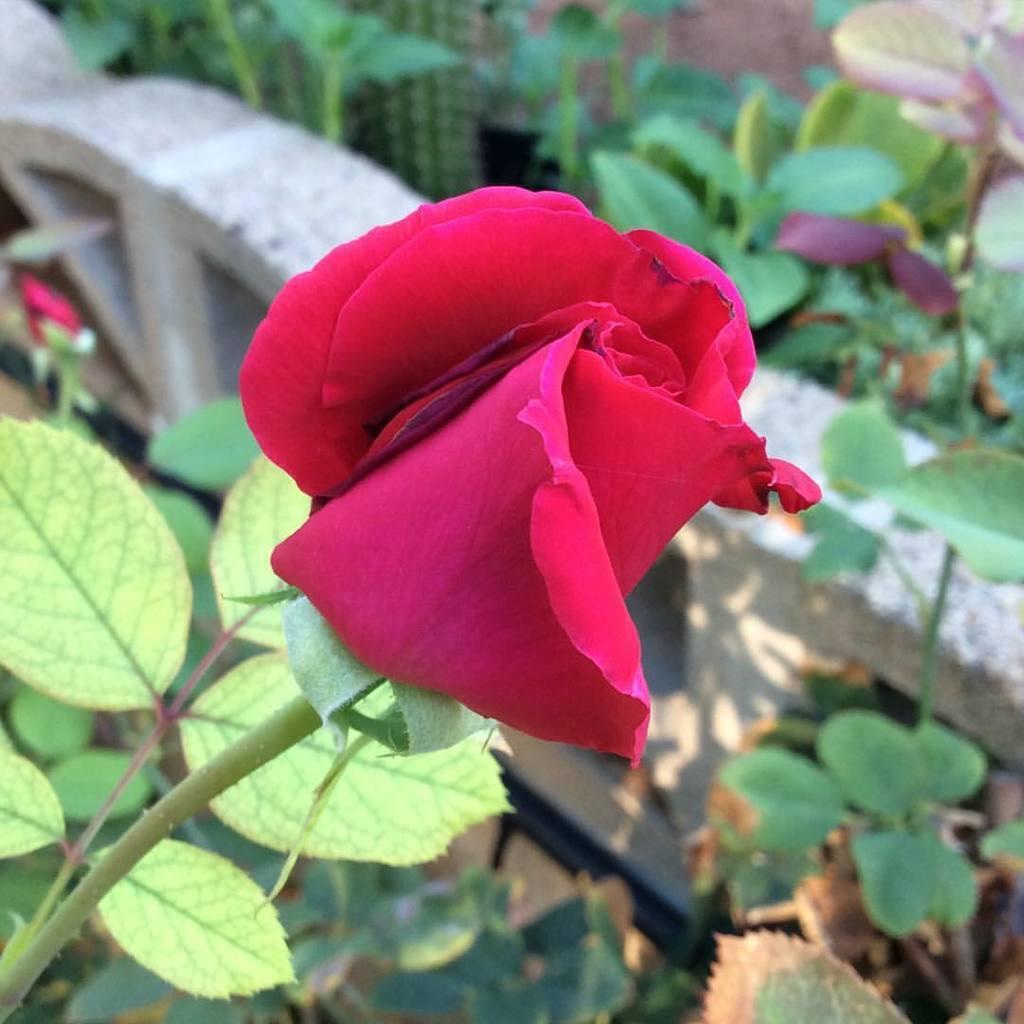Could you give a brief overview of what you see in this image? In the picture we can see a plant with a rose flower which is red in color and some railing wall beside it and some plants inside it to the path. 